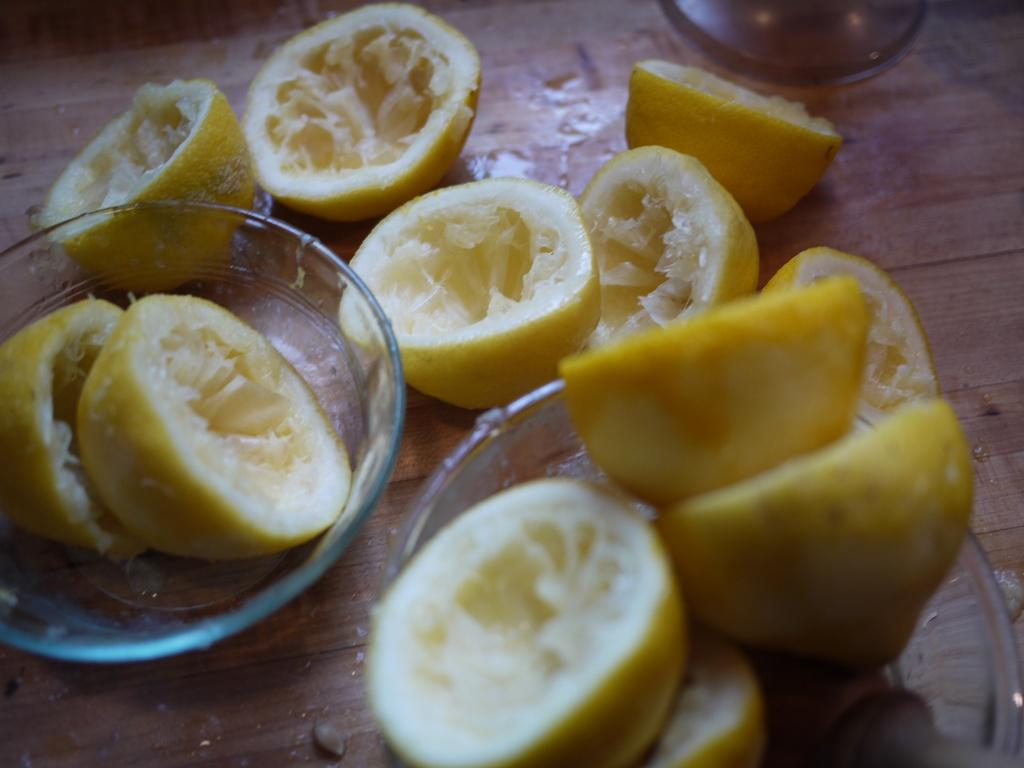What type of surface is visible in the image? There is a wooden surface in the image. What can be seen on top of the wooden surface? Lemon pieces and a glass cup are present on the wooden surface. Are there any other objects on the wooden surface? Yes, there are other objects on the wooden surface. Where is the grandfather sitting in the image? There is no grandfather present in the image. What type of bell can be seen hanging from the mailbox in the image? There is no mailbox or bell present in the image. 